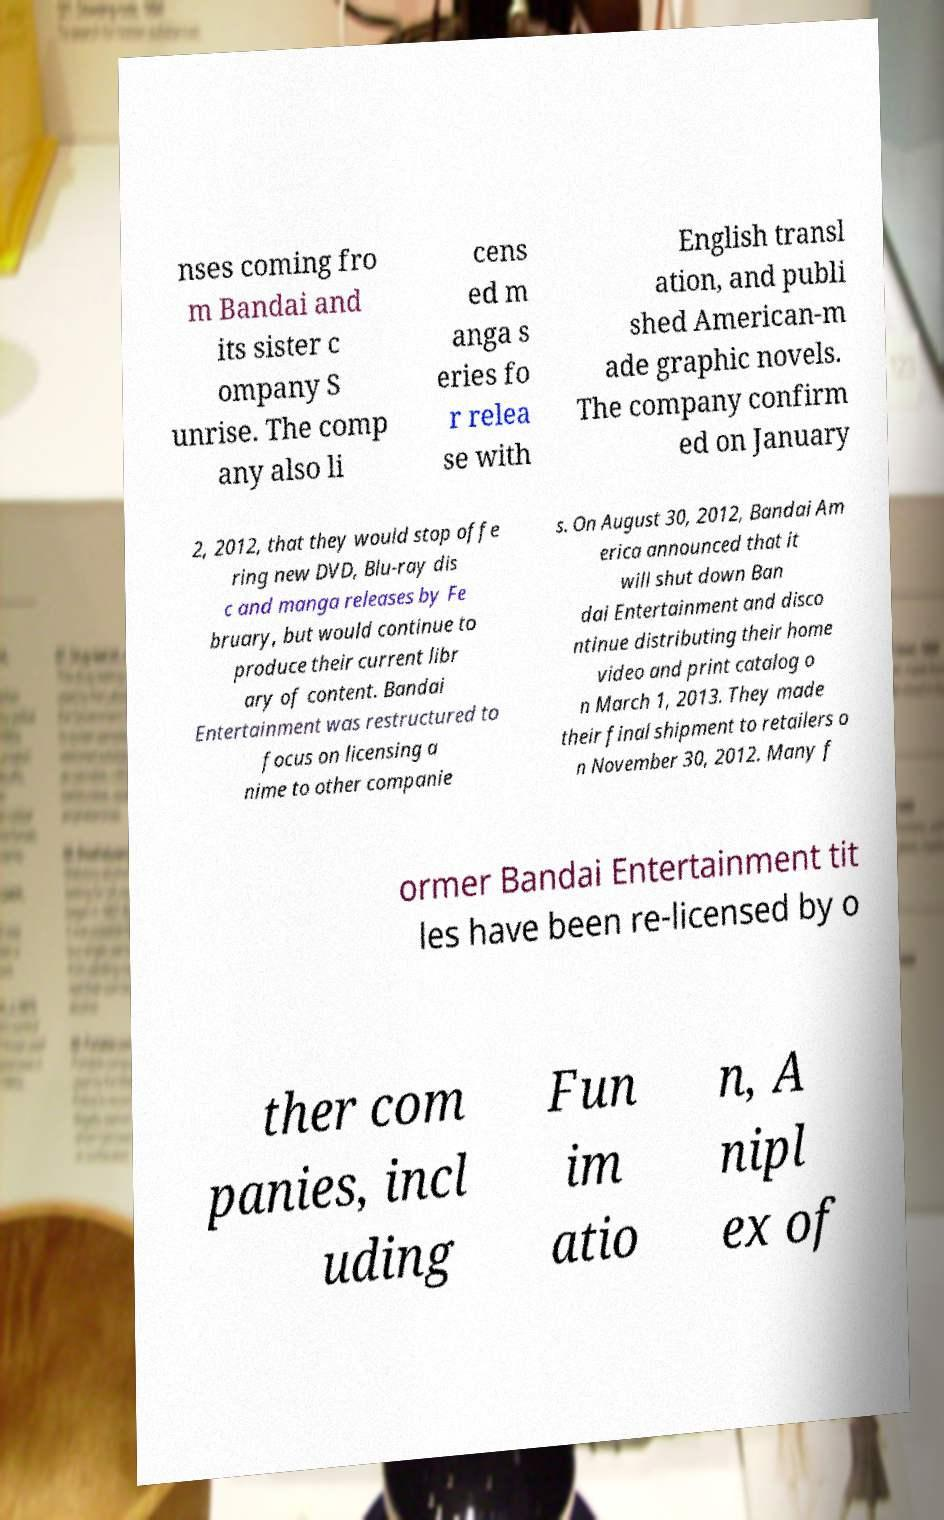Can you read and provide the text displayed in the image?This photo seems to have some interesting text. Can you extract and type it out for me? nses coming fro m Bandai and its sister c ompany S unrise. The comp any also li cens ed m anga s eries fo r relea se with English transl ation, and publi shed American-m ade graphic novels. The company confirm ed on January 2, 2012, that they would stop offe ring new DVD, Blu-ray dis c and manga releases by Fe bruary, but would continue to produce their current libr ary of content. Bandai Entertainment was restructured to focus on licensing a nime to other companie s. On August 30, 2012, Bandai Am erica announced that it will shut down Ban dai Entertainment and disco ntinue distributing their home video and print catalog o n March 1, 2013. They made their final shipment to retailers o n November 30, 2012. Many f ormer Bandai Entertainment tit les have been re-licensed by o ther com panies, incl uding Fun im atio n, A nipl ex of 